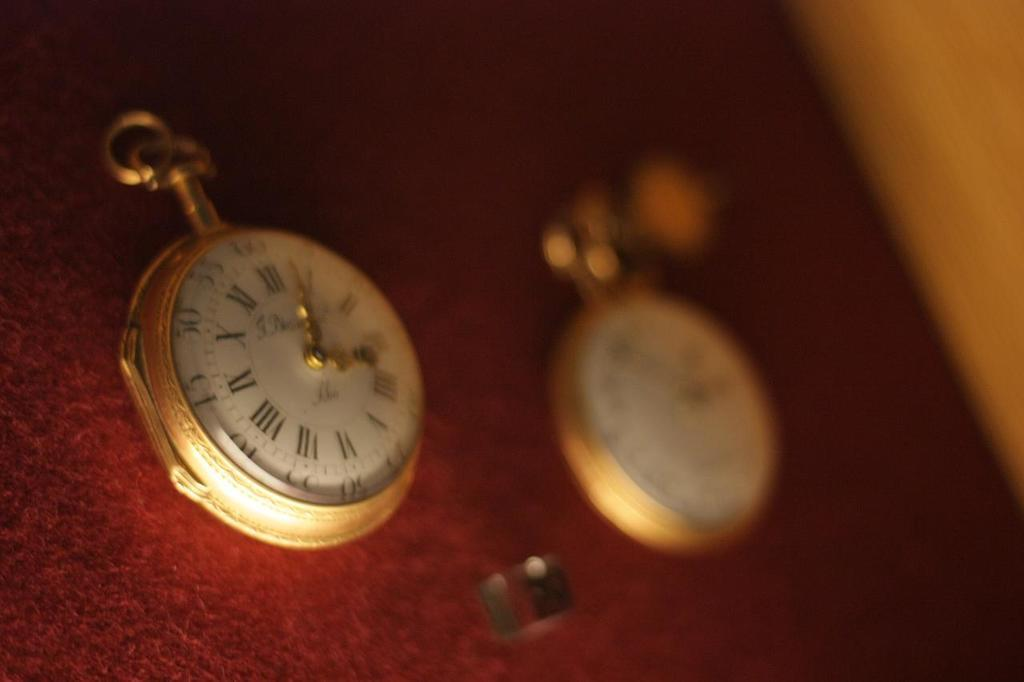<image>
Create a compact narrative representing the image presented. Two watches are shown and one is showing a time of just after three. 